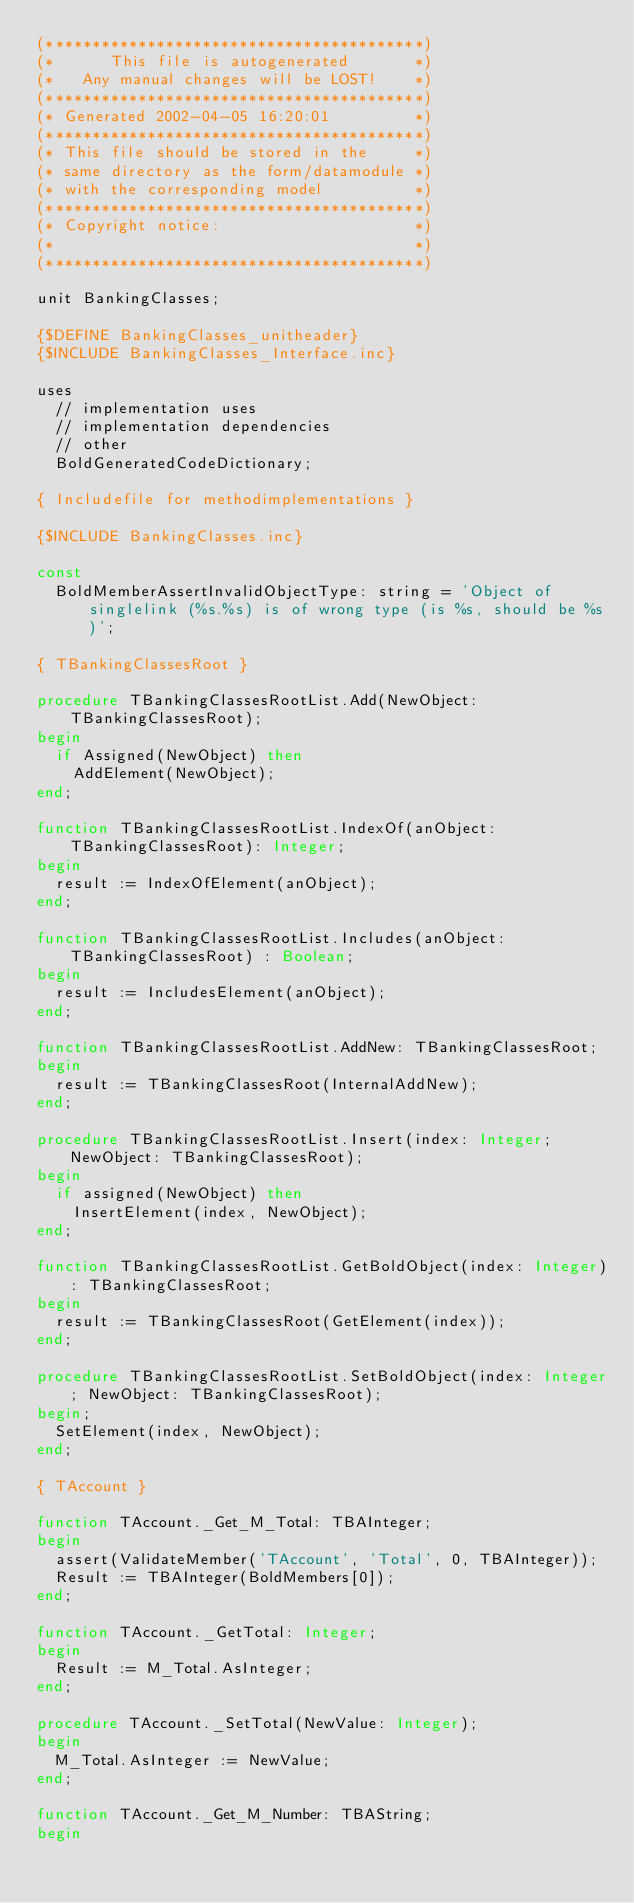Convert code to text. <code><loc_0><loc_0><loc_500><loc_500><_Pascal_>(*****************************************)
(*      This file is autogenerated       *)
(*   Any manual changes will be LOST!    *)
(*****************************************)
(* Generated 2002-04-05 16:20:01         *)
(*****************************************)
(* This file should be stored in the     *)
(* same directory as the form/datamodule *)
(* with the corresponding model          *)
(*****************************************)
(* Copyright notice:                     *)
(*                                       *)
(*****************************************)

unit BankingClasses;

{$DEFINE BankingClasses_unitheader}
{$INCLUDE BankingClasses_Interface.inc}

uses
  // implementation uses
  // implementation dependencies
  // other
  BoldGeneratedCodeDictionary;

{ Includefile for methodimplementations }

{$INCLUDE BankingClasses.inc}

const
  BoldMemberAssertInvalidObjectType: string = 'Object of singlelink (%s.%s) is of wrong type (is %s, should be %s)';

{ TBankingClassesRoot }

procedure TBankingClassesRootList.Add(NewObject: TBankingClassesRoot);
begin
  if Assigned(NewObject) then
    AddElement(NewObject);
end;

function TBankingClassesRootList.IndexOf(anObject: TBankingClassesRoot): Integer;
begin
  result := IndexOfElement(anObject);
end;

function TBankingClassesRootList.Includes(anObject: TBankingClassesRoot) : Boolean;
begin
  result := IncludesElement(anObject);
end;

function TBankingClassesRootList.AddNew: TBankingClassesRoot;
begin
  result := TBankingClassesRoot(InternalAddNew);
end;

procedure TBankingClassesRootList.Insert(index: Integer; NewObject: TBankingClassesRoot);
begin
  if assigned(NewObject) then
    InsertElement(index, NewObject);
end;

function TBankingClassesRootList.GetBoldObject(index: Integer): TBankingClassesRoot;
begin
  result := TBankingClassesRoot(GetElement(index));
end;

procedure TBankingClassesRootList.SetBoldObject(index: Integer; NewObject: TBankingClassesRoot);
begin;
  SetElement(index, NewObject);
end;

{ TAccount }

function TAccount._Get_M_Total: TBAInteger;
begin
  assert(ValidateMember('TAccount', 'Total', 0, TBAInteger));
  Result := TBAInteger(BoldMembers[0]);
end;

function TAccount._GetTotal: Integer;
begin
  Result := M_Total.AsInteger;
end;

procedure TAccount._SetTotal(NewValue: Integer);
begin
  M_Total.AsInteger := NewValue;
end;

function TAccount._Get_M_Number: TBAString;
begin</code> 